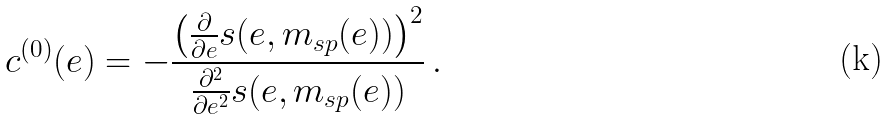<formula> <loc_0><loc_0><loc_500><loc_500>c ^ { ( 0 ) } ( e ) = - \frac { \left ( \frac { \partial } { \partial e } s ( e , m _ { s p } ( e ) ) \right ) ^ { 2 } } { \frac { \partial ^ { 2 } } { \partial e ^ { 2 } } s ( e , m _ { s p } ( e ) ) } \, .</formula> 